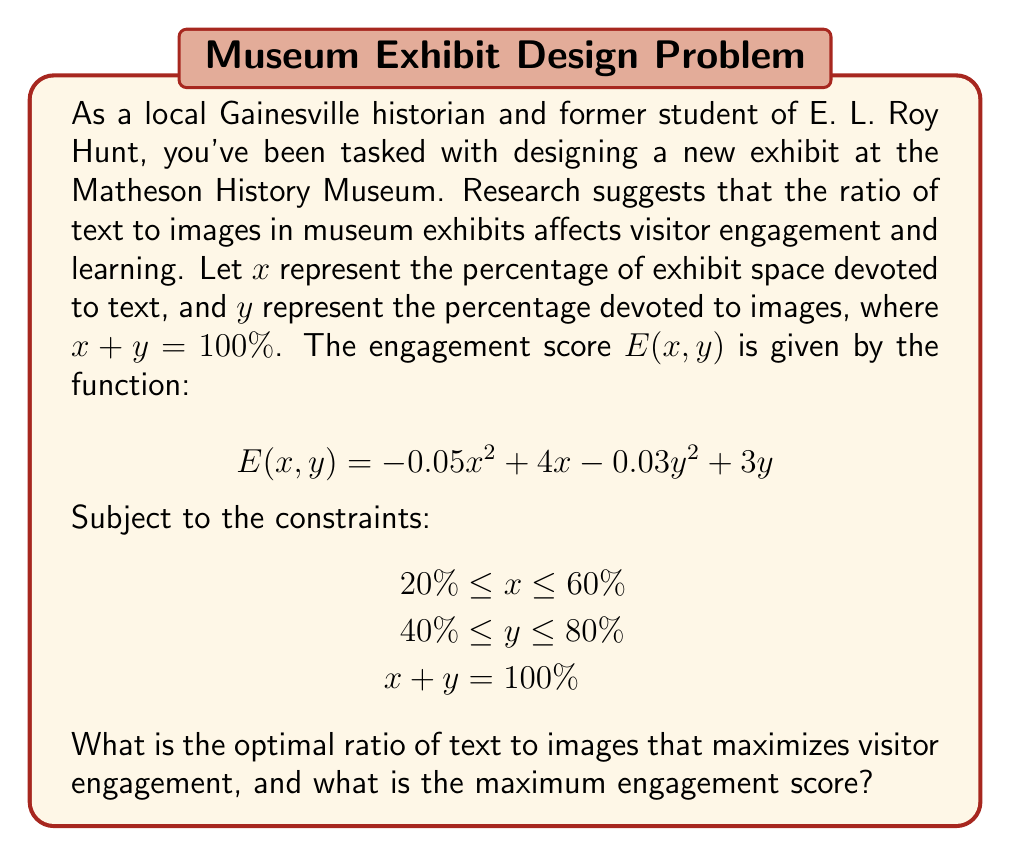Provide a solution to this math problem. To solve this optimization problem, we can follow these steps:

1) First, we can simplify our problem by eliminating one variable. Since $x + y = 100\%$, we can express $y$ in terms of $x$:

   $y = 100 - x$

2) Now we can rewrite our engagement function in terms of $x$ only:

   $E(x) = -0.05x^2 + 4x - 0.03(100-x)^2 + 3(100-x)$
   
   $= -0.05x^2 + 4x - 0.03(10000 - 200x + x^2) + 300 - 3x$
   
   $= -0.05x^2 + 4x - 300 + 6x - 0.03x^2 + 300 - 3x$
   
   $= -0.08x^2 + 7x$

3) To find the maximum of this quadratic function, we can differentiate and set it to zero:

   $\frac{dE}{dx} = -0.16x + 7 = 0$
   
   $-0.16x = -7$
   
   $x = 43.75\%$

4) The second derivative is negative ($-0.16 < 0$), confirming this is a maximum.

5) We need to check if this solution satisfies our constraints:
   
   $20\% \leq 43.75\% \leq 60\%$ (satisfied)
   
   $y = 100\% - 43.75\% = 56.25\%$
   
   $40\% \leq 56.25\% \leq 80\%$ (satisfied)

6) Therefore, the optimal solution is $x = 43.75\%$ and $y = 56.25\%$.

7) The maximum engagement score is:

   $E(43.75) = -0.08(43.75)^2 + 7(43.75) = 153.125$
Answer: The optimal ratio of text to images is 43.75% text to 56.25% images, resulting in a maximum engagement score of 153.125. 